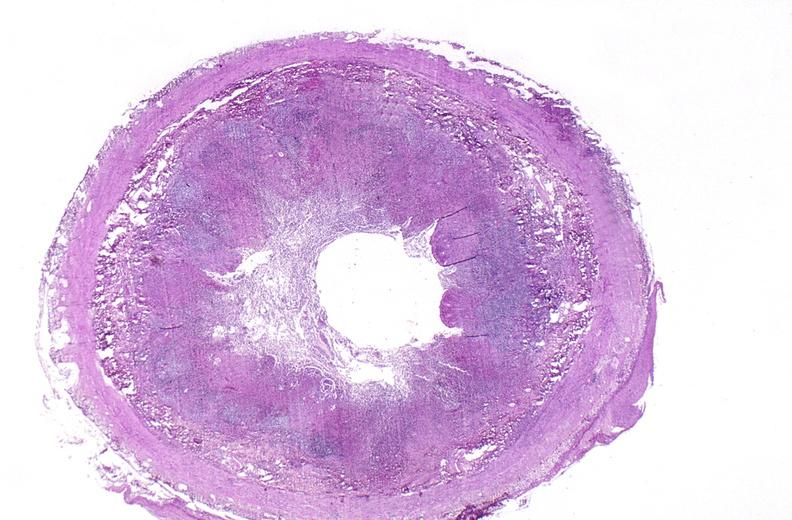does this image show appendix, acute appendicitis?
Answer the question using a single word or phrase. Yes 